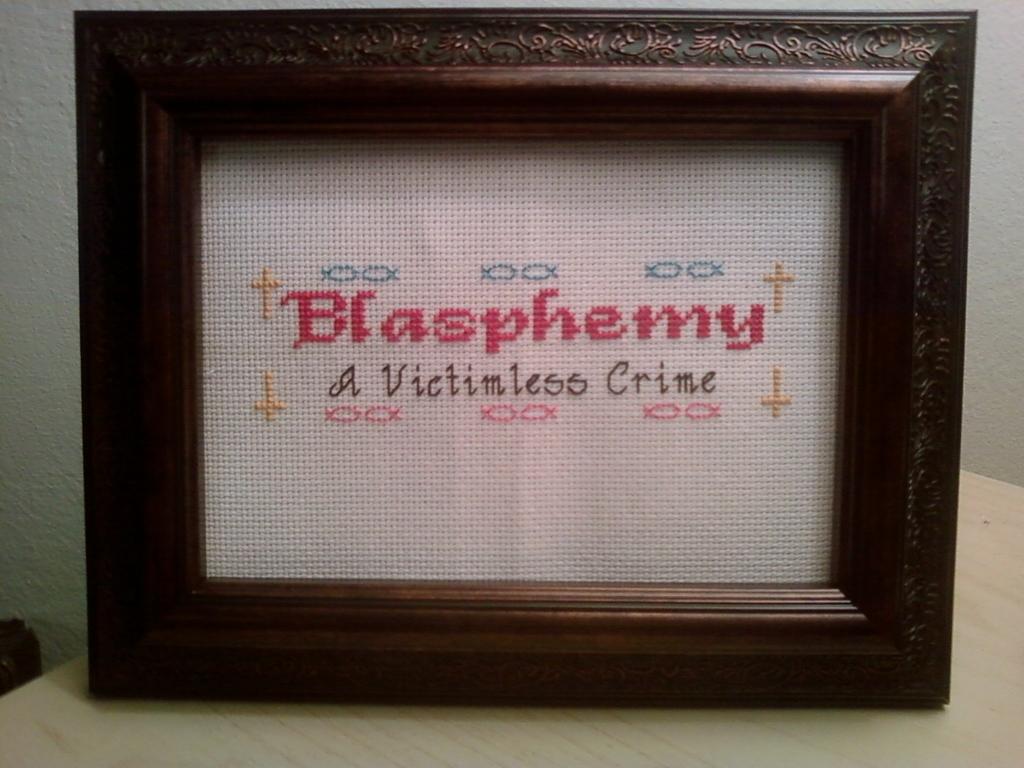What is a victimless crime?
Your answer should be very brief. Blasphemy. What is blasphemy?
Make the answer very short. A victimless crime. 